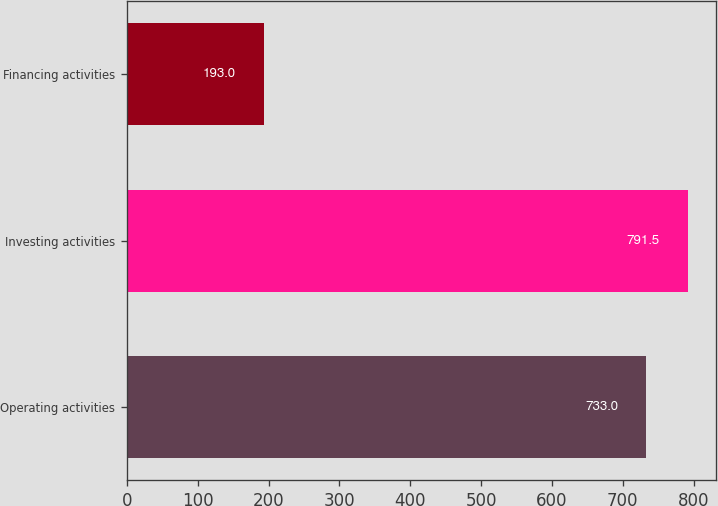Convert chart to OTSL. <chart><loc_0><loc_0><loc_500><loc_500><bar_chart><fcel>Operating activities<fcel>Investing activities<fcel>Financing activities<nl><fcel>733<fcel>791.5<fcel>193<nl></chart> 